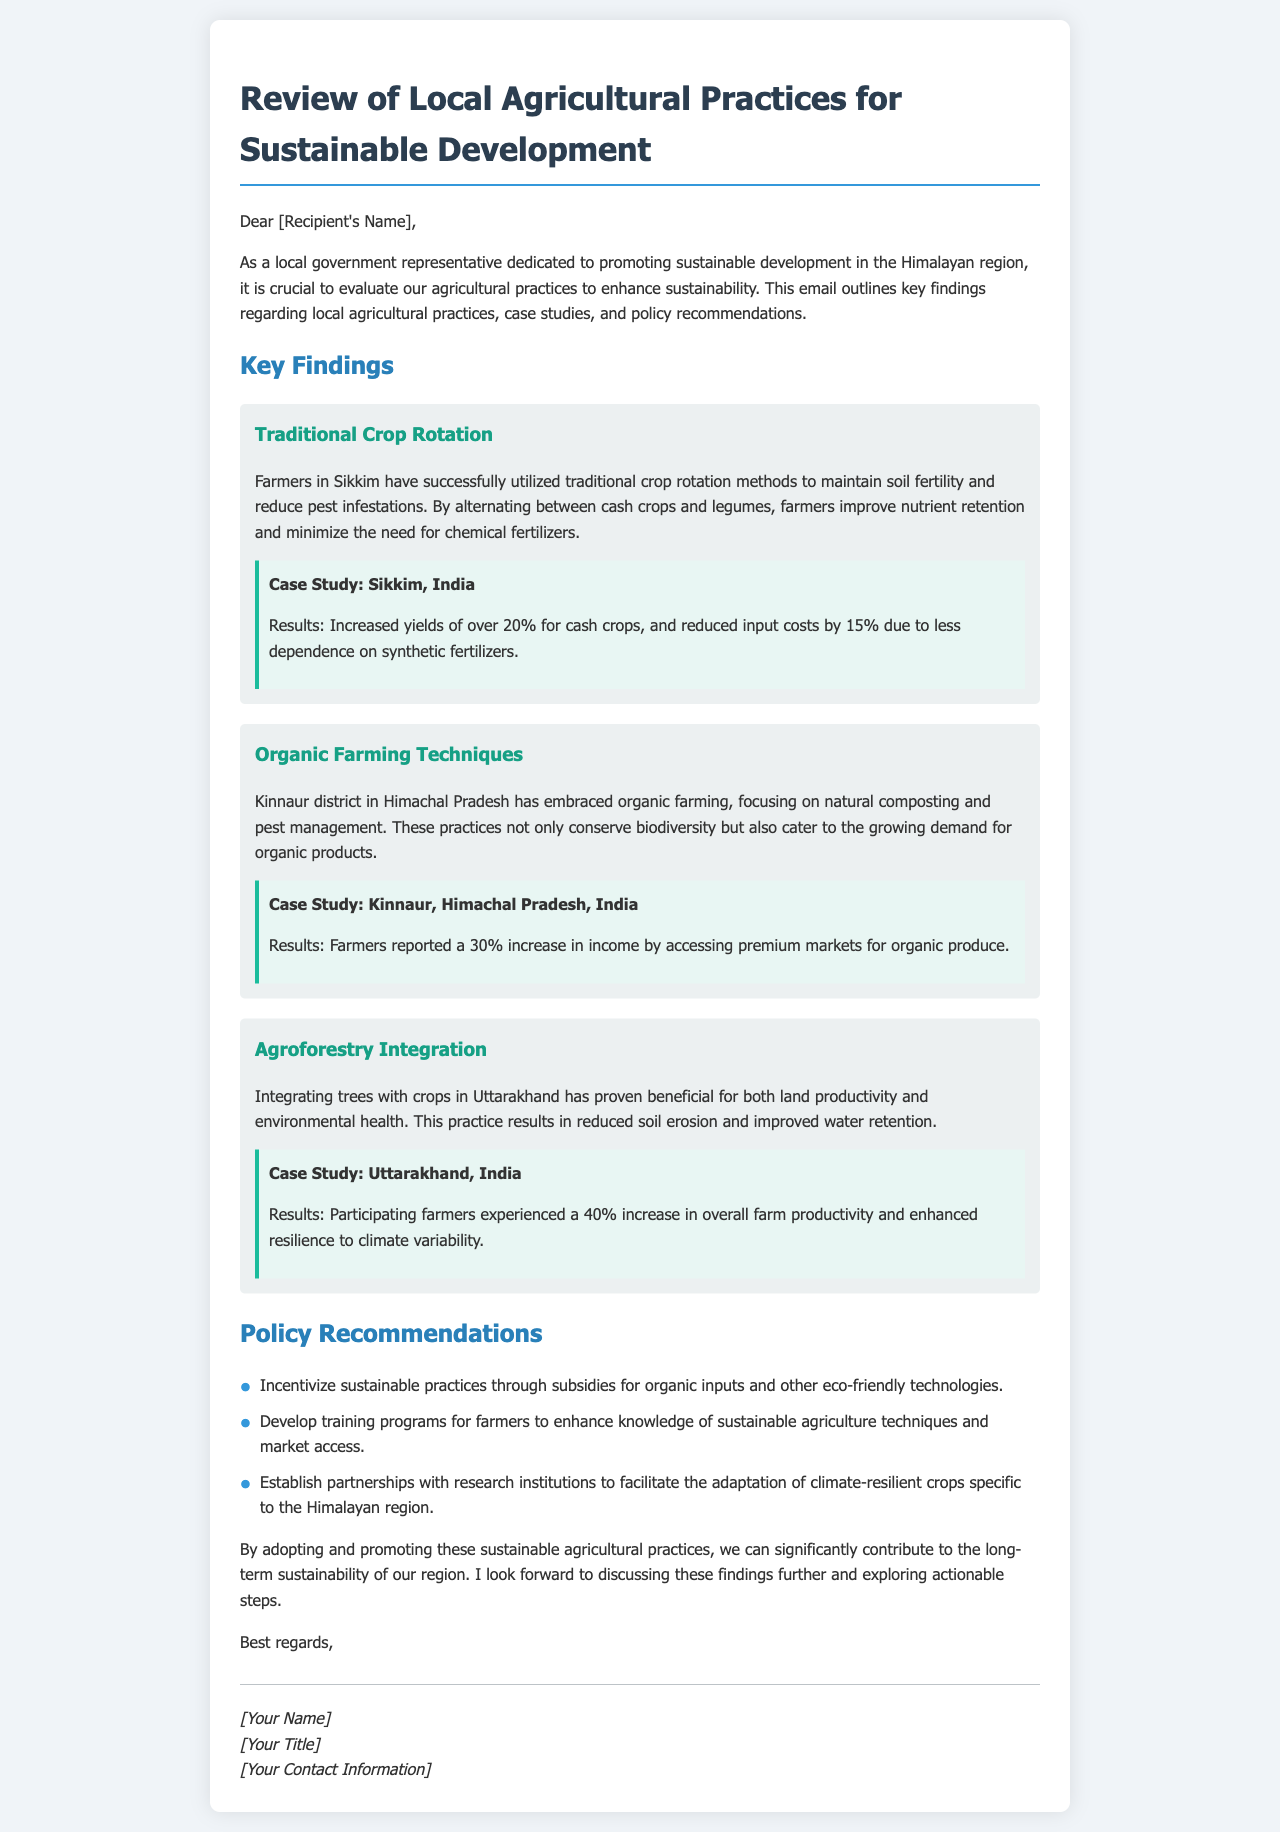What is the primary focus of the email? The email emphasizes evaluating agricultural practices in the Himalayan region to enhance sustainability.
Answer: sustainability What case study is mentioned for traditional crop rotation? It refers to the results from using traditional crop rotation in Sikkim, India.
Answer: Sikkim, India By what percentage did cash crop yields increase in Sikkim due to crop rotation? The document states that cash crop yields increased by over 20%.
Answer: 20% What type of farming practices are used in Kinnaur district? The Kinnaur district uses organic farming techniques, focusing on natural composting and pest management.
Answer: organic farming techniques What is one of the policy recommendations mentioned? One recommendation is to incentivize sustainable practices through subsidies for organic inputs and eco-friendly technologies.
Answer: subsidies for organic inputs How much did farmers in Kinnaur increase their income by using organic farming? The increase in income for farmers in Kinnaur was reported to be 30%.
Answer: 30% What benefit is noted for integrating agroforestry in Uttarakhand? The integration of agroforestry has resulted in reduced soil erosion and improved water retention.
Answer: reduced soil erosion What is the specific focus of the partnerships with research institutions? The partnerships aim to facilitate the adaptation of climate-resilient crops specific to the Himalayan region.
Answer: climate-resilient crops What is the main goal of evaluating local agricultural practices? The goal is to promote sustainable development in the Himalayan region.
Answer: sustainable development 